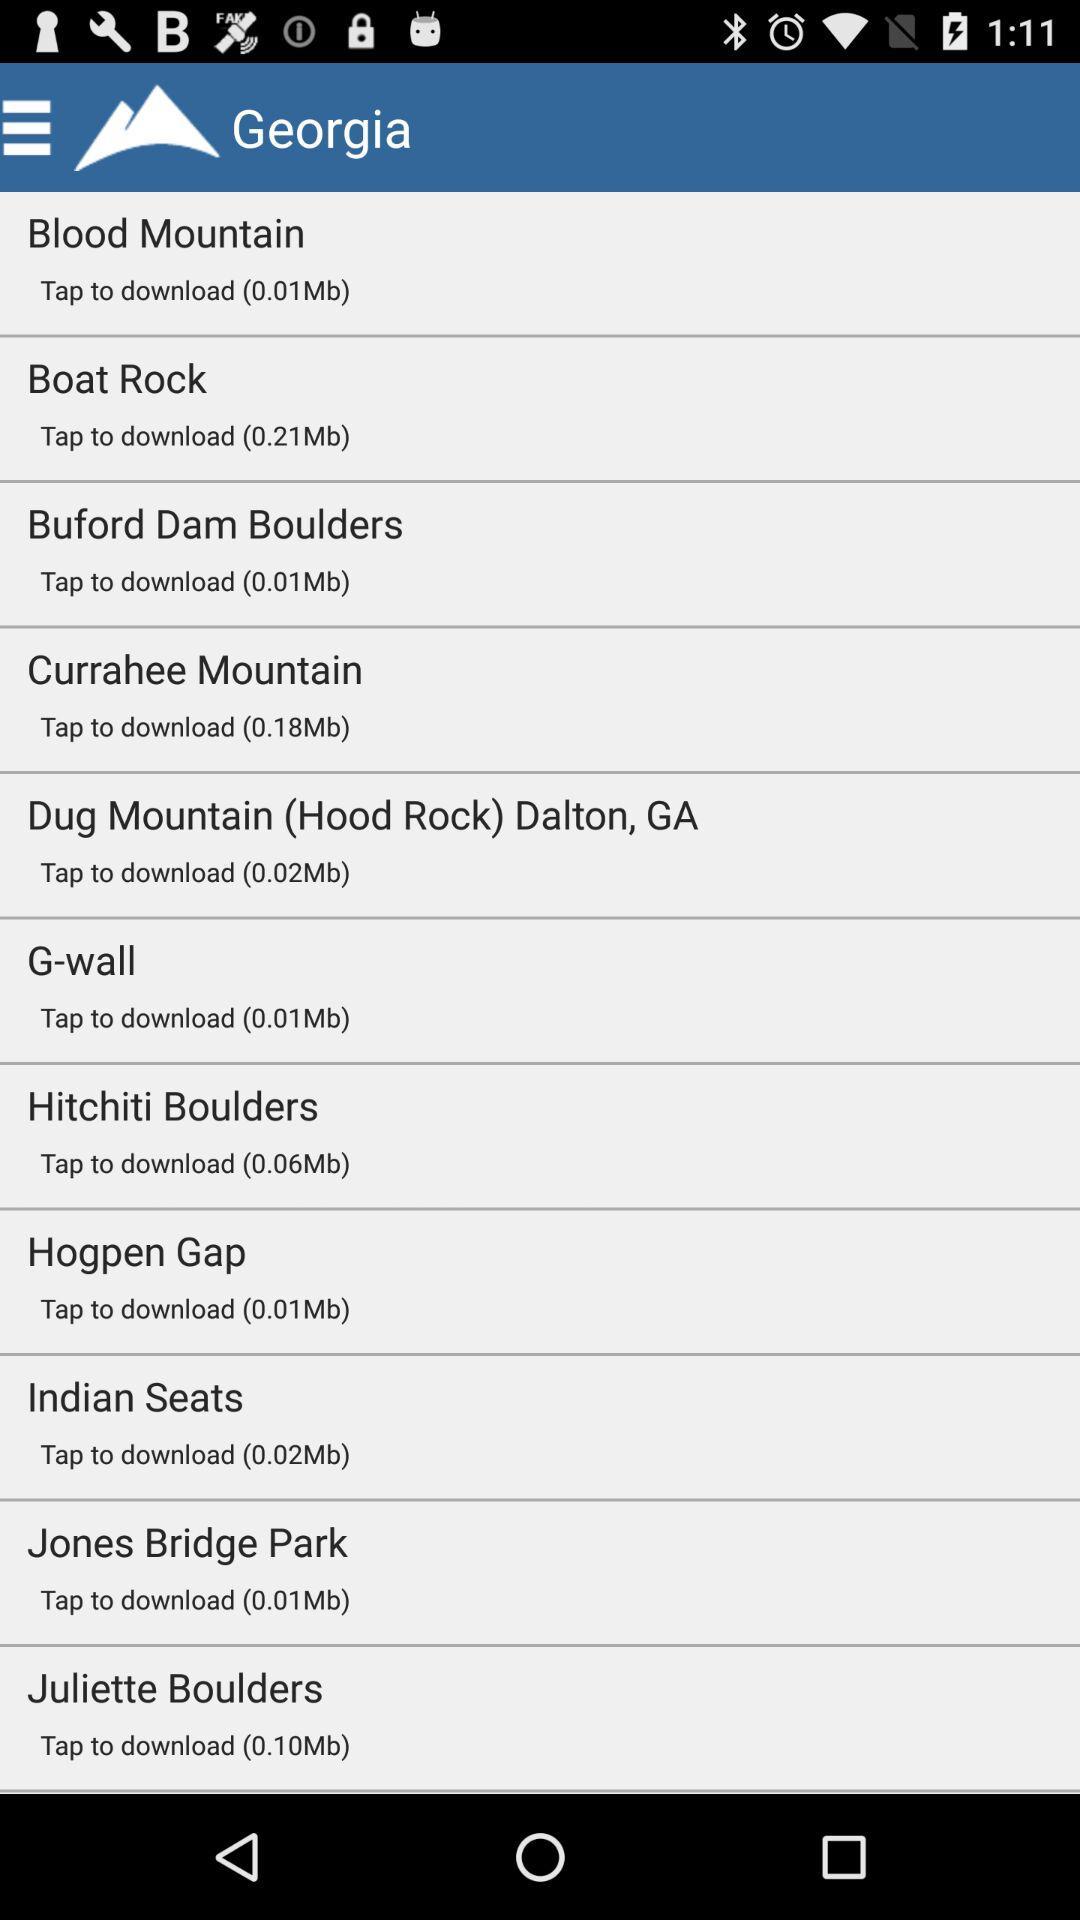How many MB are required to download "Boat Rock"? "Boat Rock" requires 0.21 MB to download. 